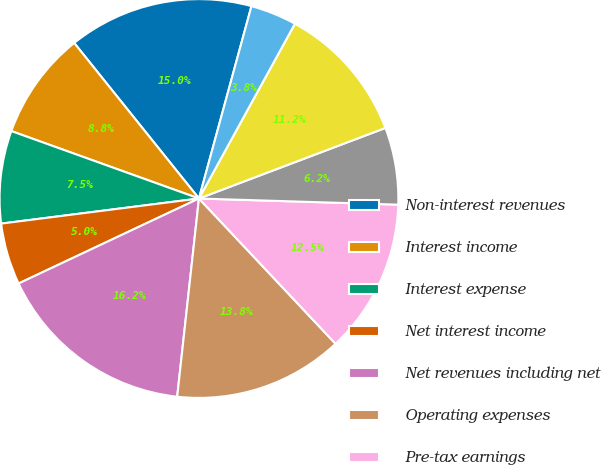<chart> <loc_0><loc_0><loc_500><loc_500><pie_chart><fcel>Non-interest revenues<fcel>Interest income<fcel>Interest expense<fcel>Net interest income<fcel>Net revenues including net<fcel>Operating expenses<fcel>Pre-tax earnings<fcel>Provision for taxes<fcel>Net earnings<fcel>Preferred stock dividends<nl><fcel>15.0%<fcel>8.75%<fcel>7.5%<fcel>5.0%<fcel>16.25%<fcel>13.75%<fcel>12.5%<fcel>6.25%<fcel>11.25%<fcel>3.75%<nl></chart> 